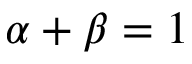<formula> <loc_0><loc_0><loc_500><loc_500>\alpha + \beta = 1</formula> 